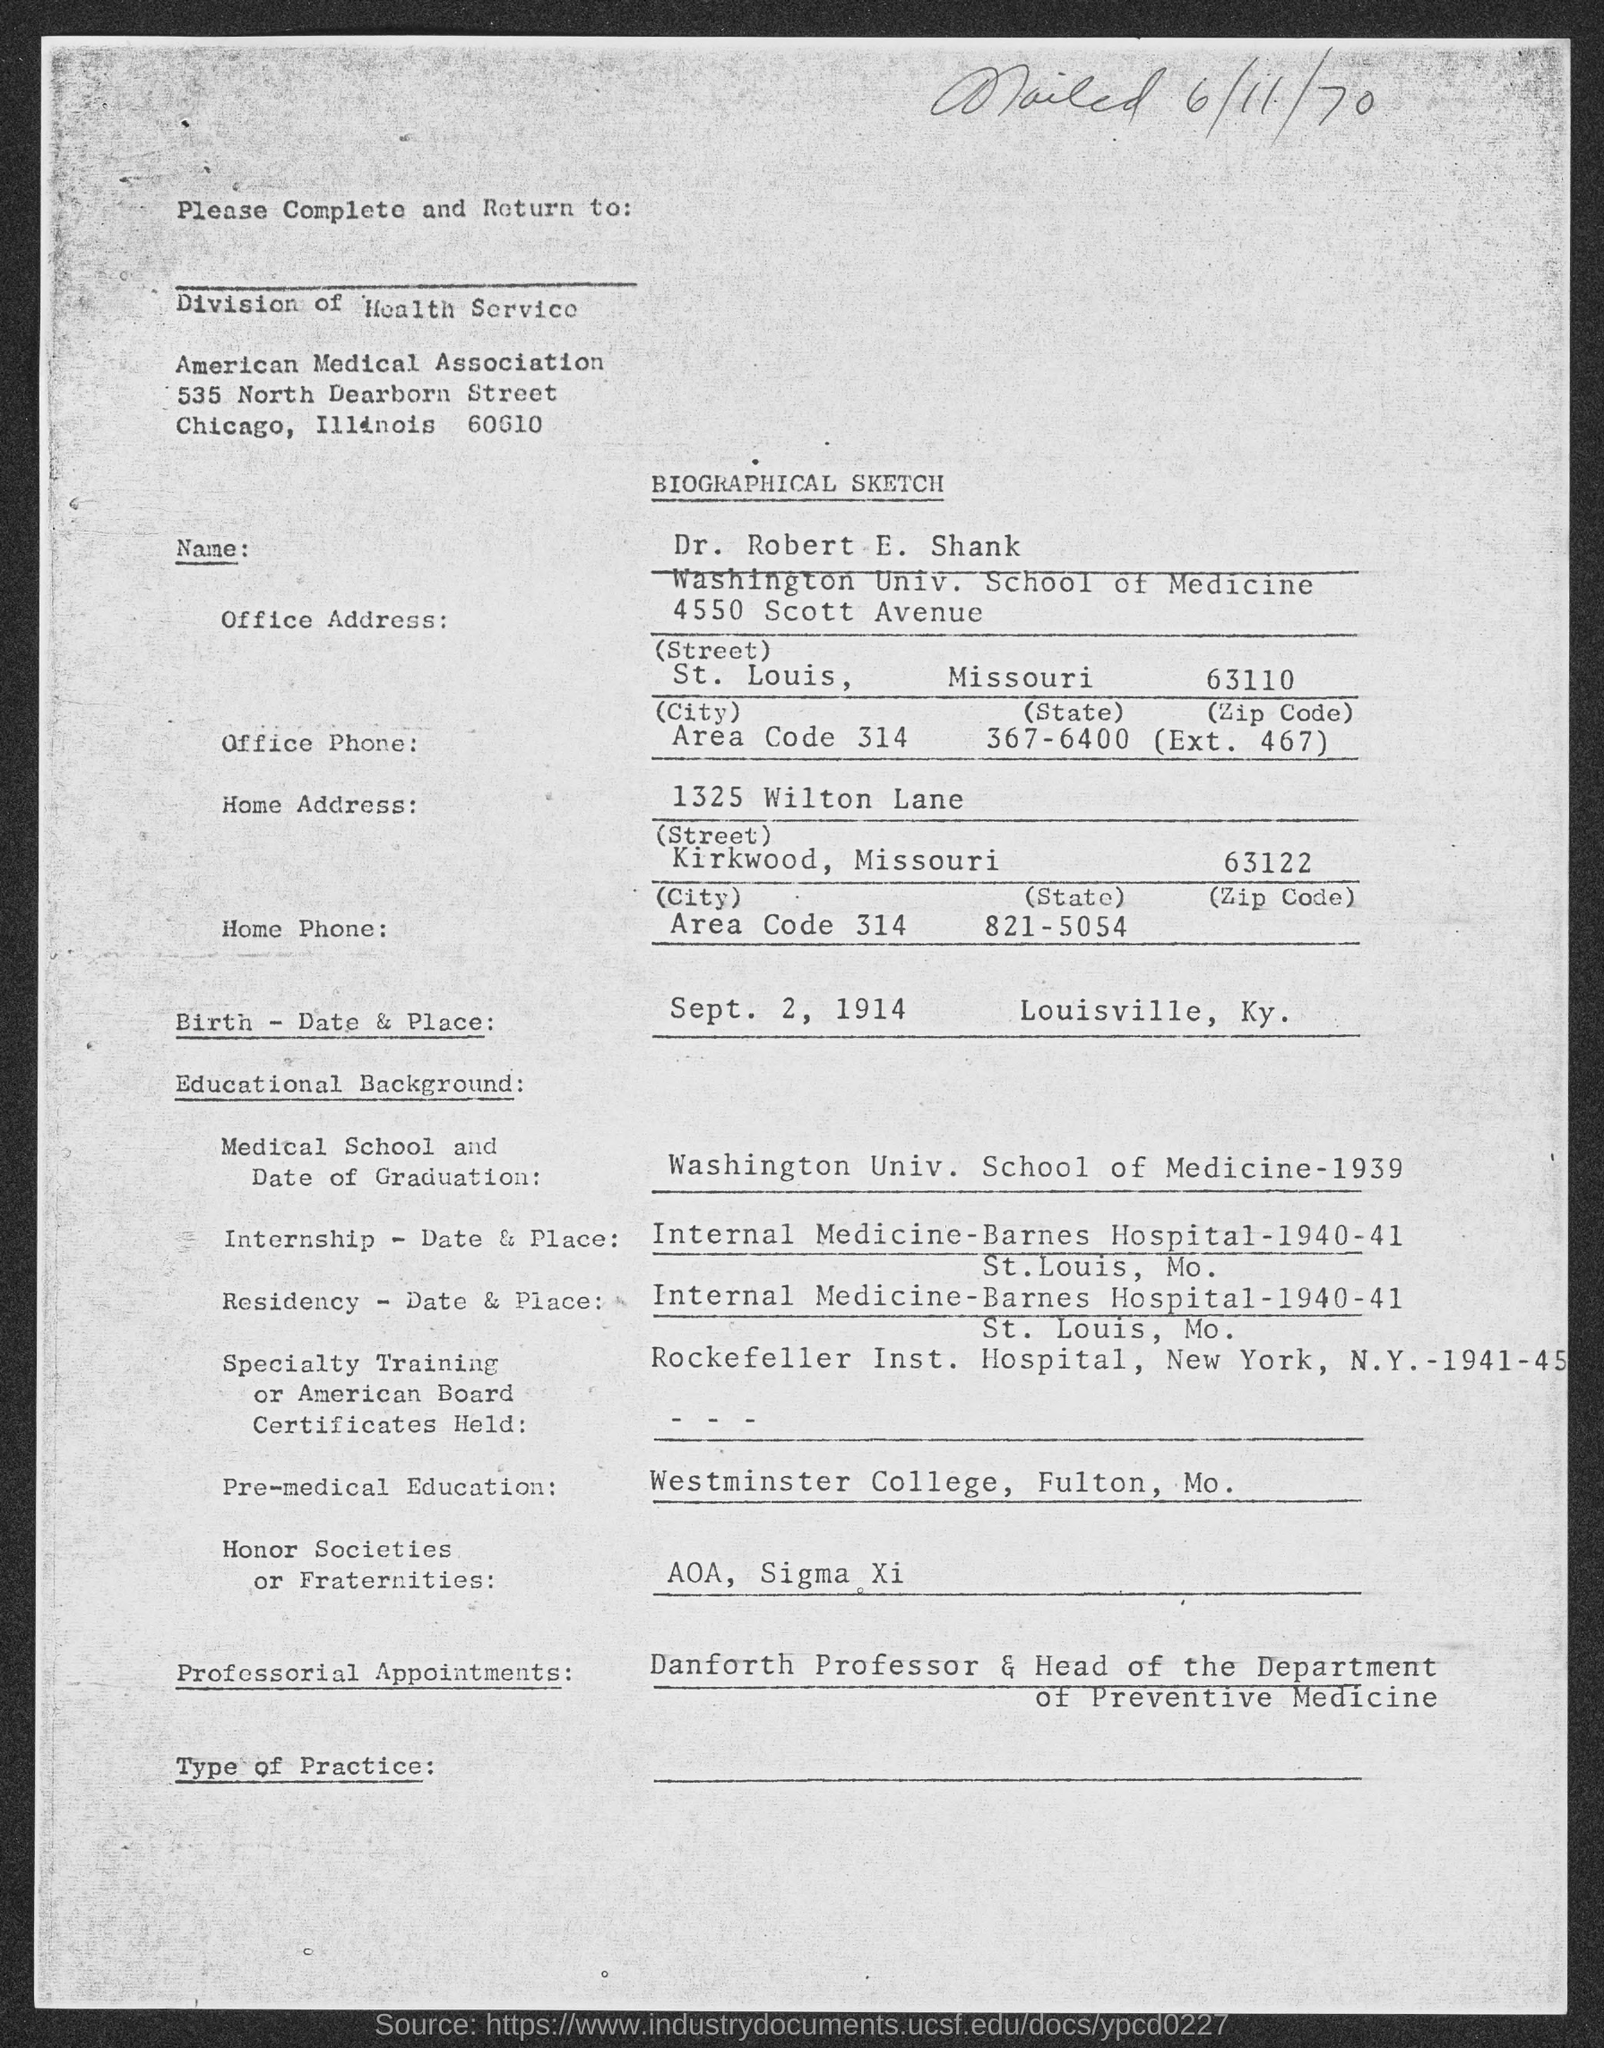When was it mailed?
Ensure brevity in your answer.  6/11/70. What is the Name?
Your answer should be compact. Dr. Robert E. Shank. What is the Birth date?
Your answer should be very brief. Sept. 2, 1914. What is the Birth place?
Provide a short and direct response. Louisville, Ky. 